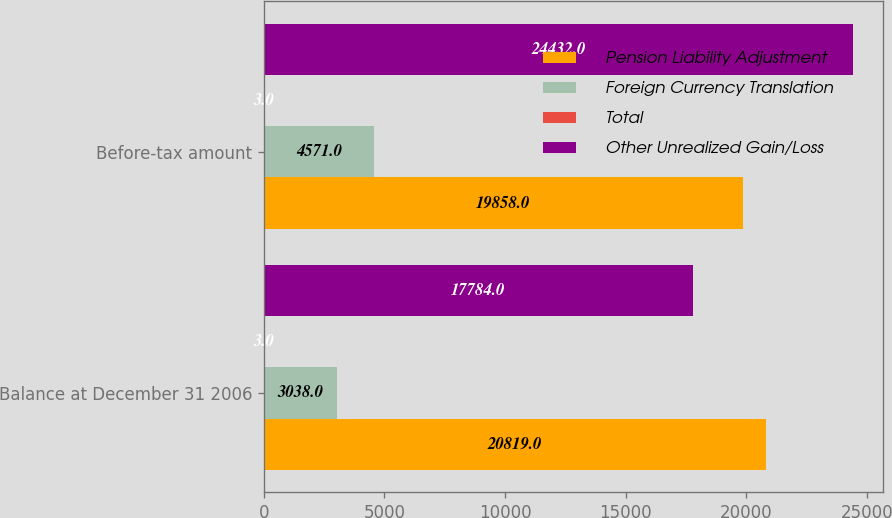<chart> <loc_0><loc_0><loc_500><loc_500><stacked_bar_chart><ecel><fcel>Balance at December 31 2006<fcel>Before-tax amount<nl><fcel>Pension Liability Adjustment<fcel>20819<fcel>19858<nl><fcel>Foreign Currency Translation<fcel>3038<fcel>4571<nl><fcel>Total<fcel>3<fcel>3<nl><fcel>Other Unrealized Gain/Loss<fcel>17784<fcel>24432<nl></chart> 